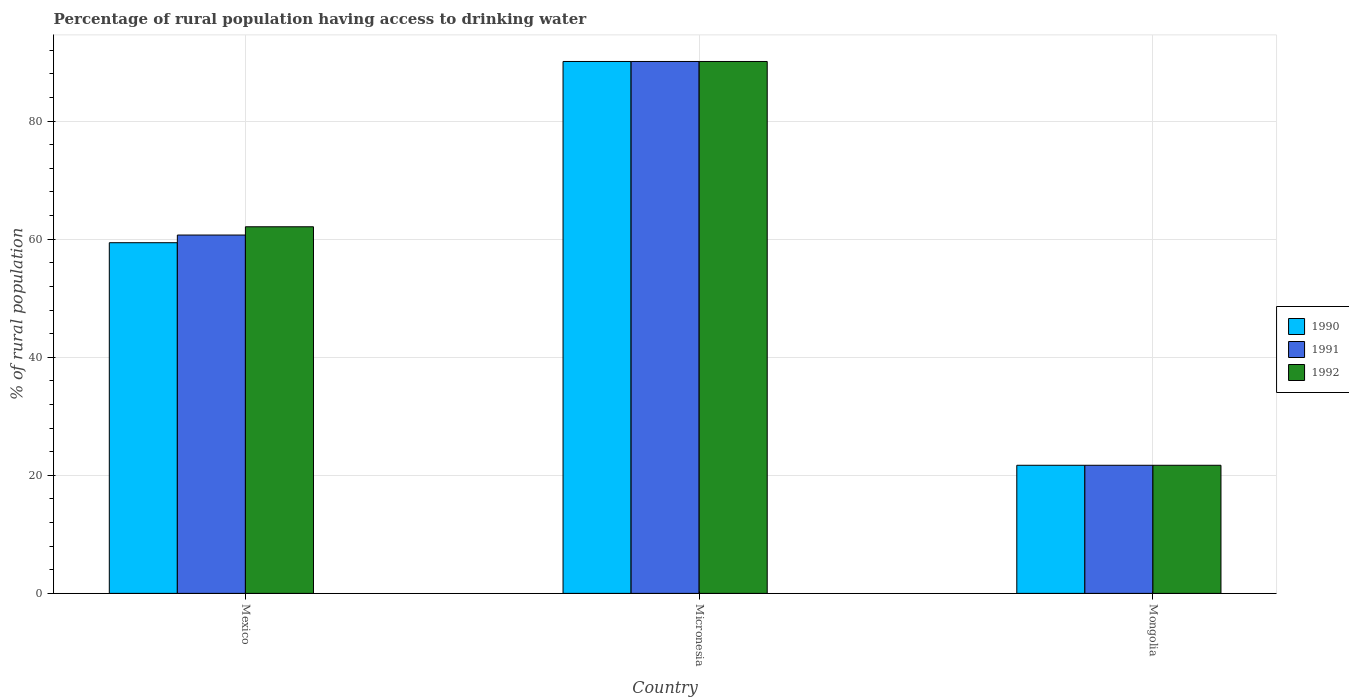Are the number of bars on each tick of the X-axis equal?
Give a very brief answer. Yes. How many bars are there on the 2nd tick from the left?
Give a very brief answer. 3. What is the label of the 1st group of bars from the left?
Offer a terse response. Mexico. What is the percentage of rural population having access to drinking water in 1992 in Mexico?
Provide a succinct answer. 62.1. Across all countries, what is the maximum percentage of rural population having access to drinking water in 1991?
Offer a very short reply. 90.1. Across all countries, what is the minimum percentage of rural population having access to drinking water in 1991?
Keep it short and to the point. 21.7. In which country was the percentage of rural population having access to drinking water in 1990 maximum?
Provide a short and direct response. Micronesia. In which country was the percentage of rural population having access to drinking water in 1991 minimum?
Provide a succinct answer. Mongolia. What is the total percentage of rural population having access to drinking water in 1992 in the graph?
Your answer should be very brief. 173.9. What is the difference between the percentage of rural population having access to drinking water in 1992 in Mexico and that in Mongolia?
Give a very brief answer. 40.4. What is the difference between the percentage of rural population having access to drinking water in 1991 in Micronesia and the percentage of rural population having access to drinking water in 1990 in Mongolia?
Give a very brief answer. 68.4. What is the average percentage of rural population having access to drinking water in 1991 per country?
Your answer should be very brief. 57.5. What is the difference between the percentage of rural population having access to drinking water of/in 1991 and percentage of rural population having access to drinking water of/in 1990 in Mongolia?
Offer a very short reply. 0. What is the ratio of the percentage of rural population having access to drinking water in 1991 in Micronesia to that in Mongolia?
Make the answer very short. 4.15. Is the percentage of rural population having access to drinking water in 1991 in Mexico less than that in Micronesia?
Keep it short and to the point. Yes. What is the difference between the highest and the second highest percentage of rural population having access to drinking water in 1990?
Give a very brief answer. 30.7. What is the difference between the highest and the lowest percentage of rural population having access to drinking water in 1992?
Give a very brief answer. 68.4. In how many countries, is the percentage of rural population having access to drinking water in 1990 greater than the average percentage of rural population having access to drinking water in 1990 taken over all countries?
Offer a very short reply. 2. Is the sum of the percentage of rural population having access to drinking water in 1992 in Mexico and Micronesia greater than the maximum percentage of rural population having access to drinking water in 1990 across all countries?
Give a very brief answer. Yes. What does the 3rd bar from the left in Mongolia represents?
Ensure brevity in your answer.  1992. What does the 1st bar from the right in Micronesia represents?
Provide a short and direct response. 1992. Is it the case that in every country, the sum of the percentage of rural population having access to drinking water in 1991 and percentage of rural population having access to drinking water in 1992 is greater than the percentage of rural population having access to drinking water in 1990?
Provide a succinct answer. Yes. Are all the bars in the graph horizontal?
Your answer should be very brief. No. Does the graph contain any zero values?
Your answer should be compact. No. What is the title of the graph?
Offer a terse response. Percentage of rural population having access to drinking water. What is the label or title of the Y-axis?
Your answer should be very brief. % of rural population. What is the % of rural population in 1990 in Mexico?
Provide a short and direct response. 59.4. What is the % of rural population in 1991 in Mexico?
Make the answer very short. 60.7. What is the % of rural population of 1992 in Mexico?
Ensure brevity in your answer.  62.1. What is the % of rural population of 1990 in Micronesia?
Provide a short and direct response. 90.1. What is the % of rural population in 1991 in Micronesia?
Your response must be concise. 90.1. What is the % of rural population in 1992 in Micronesia?
Offer a terse response. 90.1. What is the % of rural population of 1990 in Mongolia?
Your response must be concise. 21.7. What is the % of rural population of 1991 in Mongolia?
Give a very brief answer. 21.7. What is the % of rural population in 1992 in Mongolia?
Offer a terse response. 21.7. Across all countries, what is the maximum % of rural population of 1990?
Your answer should be very brief. 90.1. Across all countries, what is the maximum % of rural population of 1991?
Make the answer very short. 90.1. Across all countries, what is the maximum % of rural population in 1992?
Ensure brevity in your answer.  90.1. Across all countries, what is the minimum % of rural population of 1990?
Your response must be concise. 21.7. Across all countries, what is the minimum % of rural population of 1991?
Offer a very short reply. 21.7. Across all countries, what is the minimum % of rural population in 1992?
Ensure brevity in your answer.  21.7. What is the total % of rural population in 1990 in the graph?
Ensure brevity in your answer.  171.2. What is the total % of rural population in 1991 in the graph?
Offer a terse response. 172.5. What is the total % of rural population of 1992 in the graph?
Provide a short and direct response. 173.9. What is the difference between the % of rural population of 1990 in Mexico and that in Micronesia?
Your answer should be very brief. -30.7. What is the difference between the % of rural population in 1991 in Mexico and that in Micronesia?
Give a very brief answer. -29.4. What is the difference between the % of rural population of 1990 in Mexico and that in Mongolia?
Ensure brevity in your answer.  37.7. What is the difference between the % of rural population in 1991 in Mexico and that in Mongolia?
Provide a short and direct response. 39. What is the difference between the % of rural population of 1992 in Mexico and that in Mongolia?
Give a very brief answer. 40.4. What is the difference between the % of rural population of 1990 in Micronesia and that in Mongolia?
Your response must be concise. 68.4. What is the difference between the % of rural population of 1991 in Micronesia and that in Mongolia?
Your answer should be compact. 68.4. What is the difference between the % of rural population in 1992 in Micronesia and that in Mongolia?
Provide a short and direct response. 68.4. What is the difference between the % of rural population of 1990 in Mexico and the % of rural population of 1991 in Micronesia?
Your answer should be compact. -30.7. What is the difference between the % of rural population of 1990 in Mexico and the % of rural population of 1992 in Micronesia?
Your response must be concise. -30.7. What is the difference between the % of rural population of 1991 in Mexico and the % of rural population of 1992 in Micronesia?
Give a very brief answer. -29.4. What is the difference between the % of rural population of 1990 in Mexico and the % of rural population of 1991 in Mongolia?
Offer a very short reply. 37.7. What is the difference between the % of rural population in 1990 in Mexico and the % of rural population in 1992 in Mongolia?
Offer a very short reply. 37.7. What is the difference between the % of rural population in 1990 in Micronesia and the % of rural population in 1991 in Mongolia?
Give a very brief answer. 68.4. What is the difference between the % of rural population in 1990 in Micronesia and the % of rural population in 1992 in Mongolia?
Your answer should be very brief. 68.4. What is the difference between the % of rural population in 1991 in Micronesia and the % of rural population in 1992 in Mongolia?
Provide a succinct answer. 68.4. What is the average % of rural population of 1990 per country?
Your answer should be compact. 57.07. What is the average % of rural population in 1991 per country?
Provide a succinct answer. 57.5. What is the average % of rural population in 1992 per country?
Provide a short and direct response. 57.97. What is the difference between the % of rural population in 1990 and % of rural population in 1991 in Mexico?
Your response must be concise. -1.3. What is the difference between the % of rural population of 1990 and % of rural population of 1992 in Mexico?
Offer a terse response. -2.7. What is the difference between the % of rural population of 1991 and % of rural population of 1992 in Mexico?
Keep it short and to the point. -1.4. What is the difference between the % of rural population of 1990 and % of rural population of 1991 in Micronesia?
Your answer should be compact. 0. What is the difference between the % of rural population of 1990 and % of rural population of 1992 in Micronesia?
Give a very brief answer. 0. What is the difference between the % of rural population of 1991 and % of rural population of 1992 in Micronesia?
Keep it short and to the point. 0. What is the difference between the % of rural population in 1990 and % of rural population in 1992 in Mongolia?
Your response must be concise. 0. What is the difference between the % of rural population in 1991 and % of rural population in 1992 in Mongolia?
Keep it short and to the point. 0. What is the ratio of the % of rural population in 1990 in Mexico to that in Micronesia?
Make the answer very short. 0.66. What is the ratio of the % of rural population in 1991 in Mexico to that in Micronesia?
Keep it short and to the point. 0.67. What is the ratio of the % of rural population in 1992 in Mexico to that in Micronesia?
Keep it short and to the point. 0.69. What is the ratio of the % of rural population in 1990 in Mexico to that in Mongolia?
Your answer should be compact. 2.74. What is the ratio of the % of rural population in 1991 in Mexico to that in Mongolia?
Provide a short and direct response. 2.8. What is the ratio of the % of rural population of 1992 in Mexico to that in Mongolia?
Keep it short and to the point. 2.86. What is the ratio of the % of rural population of 1990 in Micronesia to that in Mongolia?
Offer a terse response. 4.15. What is the ratio of the % of rural population of 1991 in Micronesia to that in Mongolia?
Your answer should be very brief. 4.15. What is the ratio of the % of rural population in 1992 in Micronesia to that in Mongolia?
Give a very brief answer. 4.15. What is the difference between the highest and the second highest % of rural population in 1990?
Offer a terse response. 30.7. What is the difference between the highest and the second highest % of rural population in 1991?
Your answer should be very brief. 29.4. What is the difference between the highest and the lowest % of rural population of 1990?
Provide a succinct answer. 68.4. What is the difference between the highest and the lowest % of rural population in 1991?
Your answer should be compact. 68.4. What is the difference between the highest and the lowest % of rural population of 1992?
Keep it short and to the point. 68.4. 